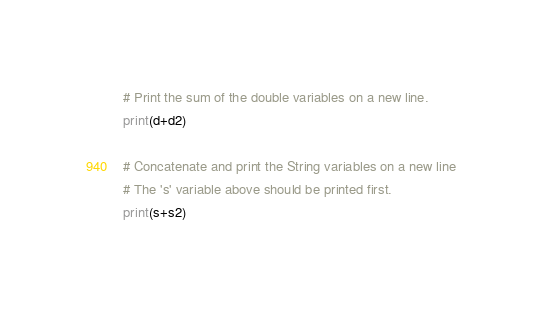<code> <loc_0><loc_0><loc_500><loc_500><_Python_>
# Print the sum of the double variables on a new line.
print(d+d2)

# Concatenate and print the String variables on a new line
# The 's' variable above should be printed first.
print(s+s2)
</code> 